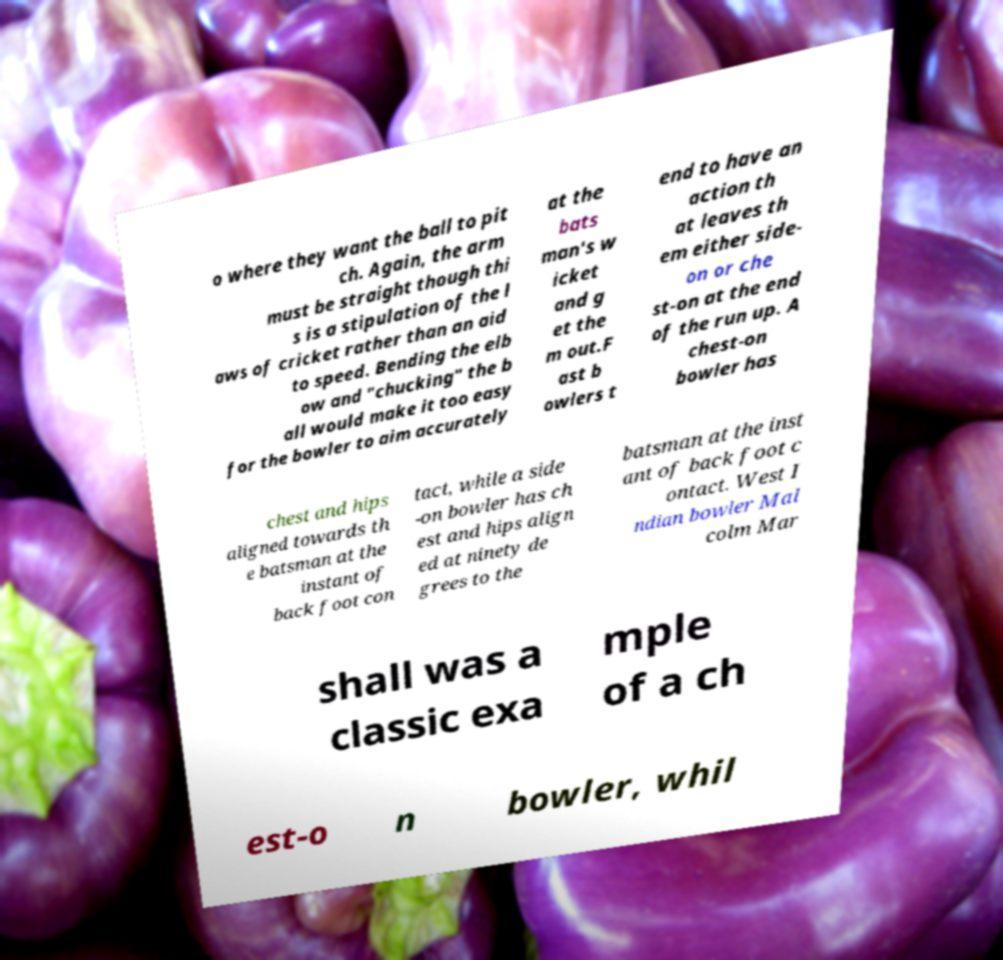For documentation purposes, I need the text within this image transcribed. Could you provide that? o where they want the ball to pit ch. Again, the arm must be straight though thi s is a stipulation of the l aws of cricket rather than an aid to speed. Bending the elb ow and "chucking" the b all would make it too easy for the bowler to aim accurately at the bats man's w icket and g et the m out.F ast b owlers t end to have an action th at leaves th em either side- on or che st-on at the end of the run up. A chest-on bowler has chest and hips aligned towards th e batsman at the instant of back foot con tact, while a side -on bowler has ch est and hips align ed at ninety de grees to the batsman at the inst ant of back foot c ontact. West I ndian bowler Mal colm Mar shall was a classic exa mple of a ch est-o n bowler, whil 